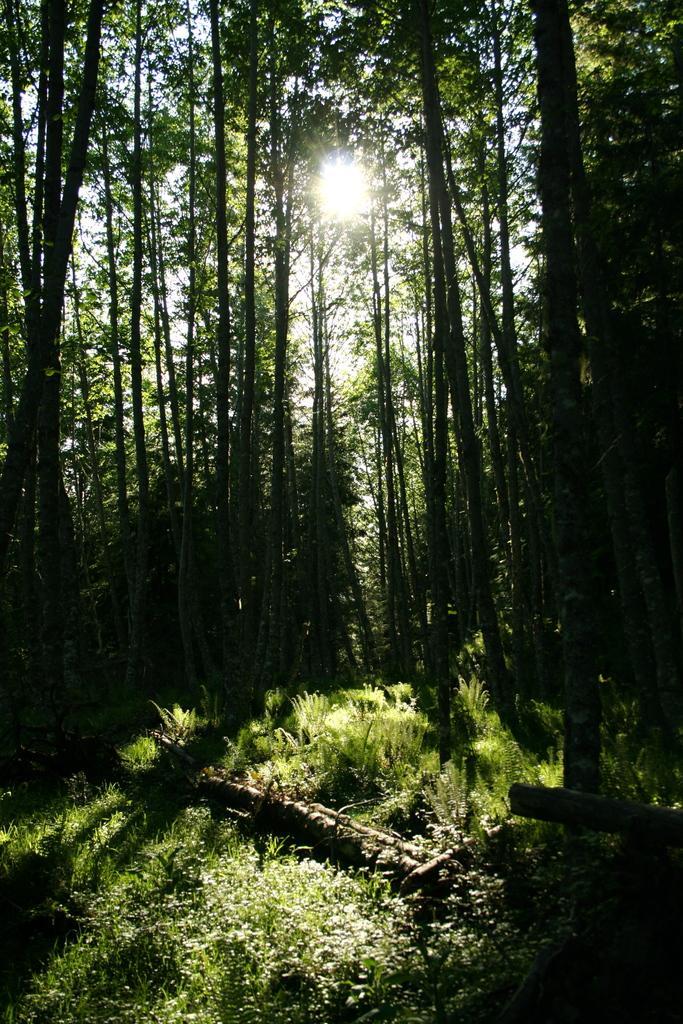Please provide a concise description of this image. In this picture we can see sun rises, grass and trees. 